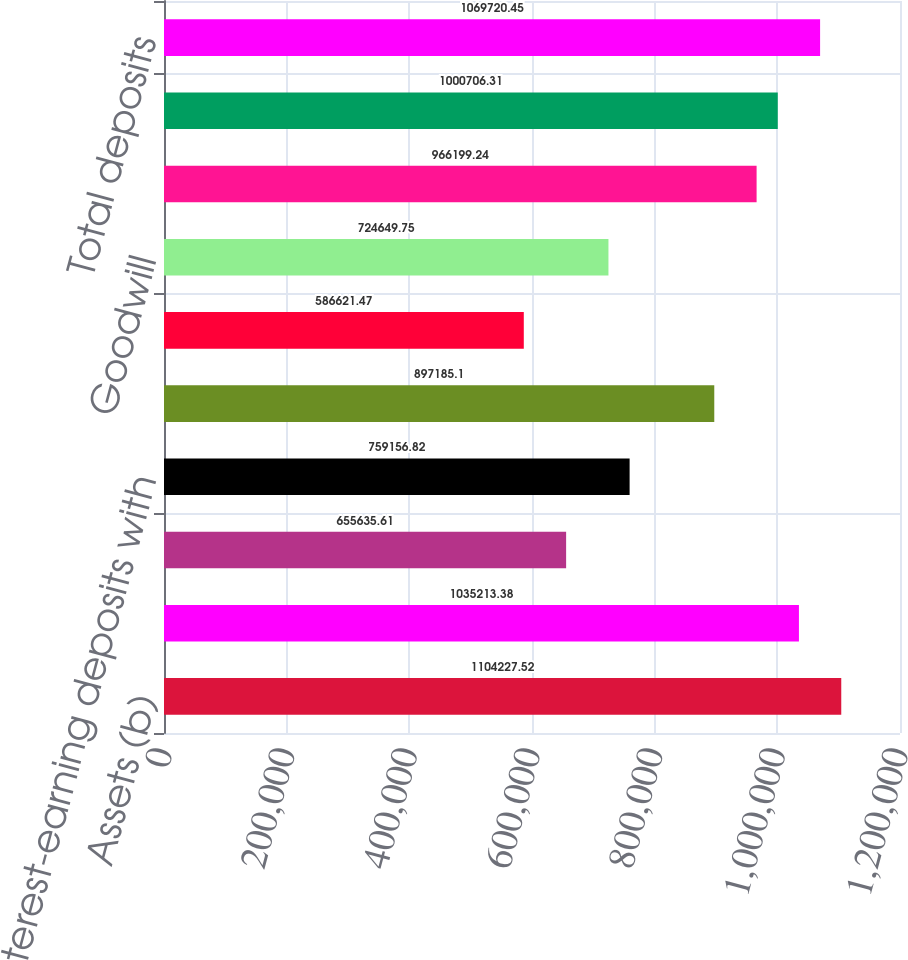<chart> <loc_0><loc_0><loc_500><loc_500><bar_chart><fcel>Assets (b)<fcel>Loans (b) (c)<fcel>Allowance for loan and lease<fcel>Interest-earning deposits with<fcel>Investment securities (b)<fcel>Loans held for sale (c)<fcel>Goodwill<fcel>Noninterest-bearing deposits<fcel>Interest-bearing deposits<fcel>Total deposits<nl><fcel>1.10423e+06<fcel>1.03521e+06<fcel>655636<fcel>759157<fcel>897185<fcel>586621<fcel>724650<fcel>966199<fcel>1.00071e+06<fcel>1.06972e+06<nl></chart> 